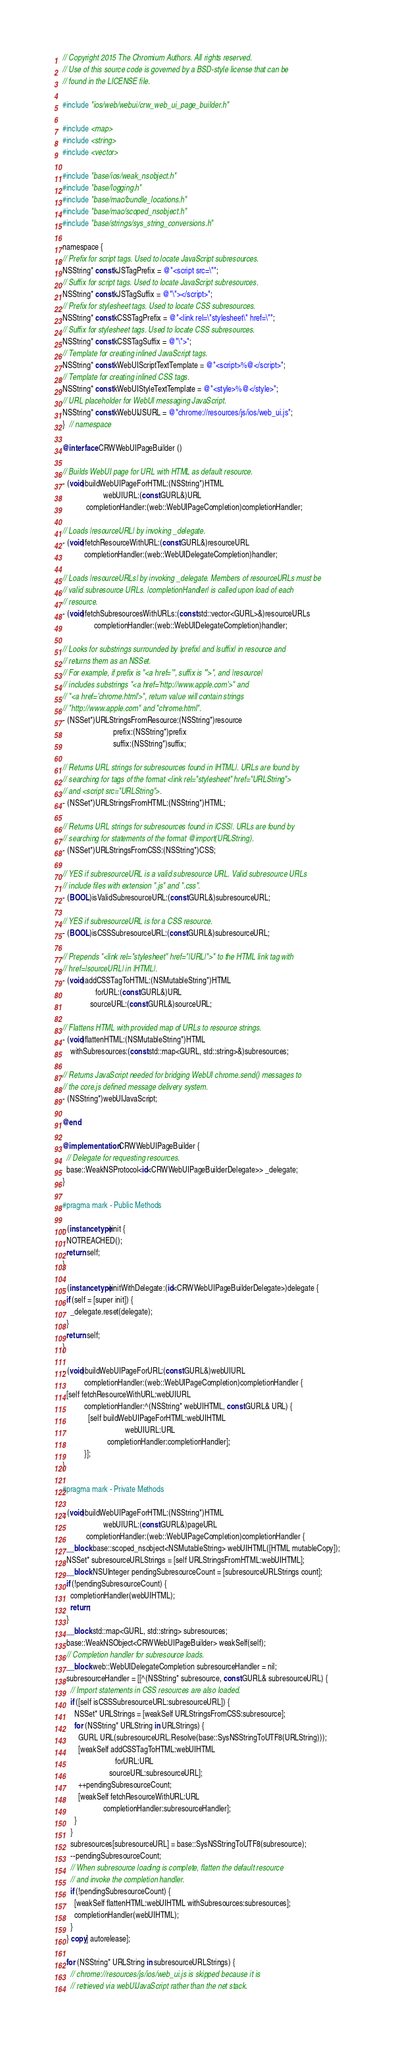Convert code to text. <code><loc_0><loc_0><loc_500><loc_500><_ObjectiveC_>// Copyright 2015 The Chromium Authors. All rights reserved.
// Use of this source code is governed by a BSD-style license that can be
// found in the LICENSE file.

#include "ios/web/webui/crw_web_ui_page_builder.h"

#include <map>
#include <string>
#include <vector>

#include "base/ios/weak_nsobject.h"
#include "base/logging.h"
#include "base/mac/bundle_locations.h"
#include "base/mac/scoped_nsobject.h"
#include "base/strings/sys_string_conversions.h"

namespace {
// Prefix for script tags. Used to locate JavaScript subresources.
NSString* const kJSTagPrefix = @"<script src=\"";
// Suffix for script tags. Used to locate JavaScript subresources.
NSString* const kJSTagSuffix = @"\"></script>";
// Prefix for stylesheet tags. Used to locate CSS subresources.
NSString* const kCSSTagPrefix = @"<link rel=\"stylesheet\" href=\"";
// Suffix for stylesheet tags. Used to locate CSS subresources.
NSString* const kCSSTagSuffix = @"\">";
// Template for creating inlined JavaScript tags.
NSString* const kWebUIScriptTextTemplate = @"<script>%@</script>";
// Template for creating inlined CSS tags.
NSString* const kWebUIStyleTextTemplate = @"<style>%@</style>";
// URL placeholder for WebUI messaging JavaScript.
NSString* const kWebUIJSURL = @"chrome://resources/js/ios/web_ui.js";
}  // namespace

@interface CRWWebUIPageBuilder ()

// Builds WebUI page for URL with HTML as default resource.
- (void)buildWebUIPageForHTML:(NSString*)HTML
                     webUIURL:(const GURL&)URL
            completionHandler:(web::WebUIPageCompletion)completionHandler;

// Loads |resourceURL| by invoking _delegate.
- (void)fetchResourceWithURL:(const GURL&)resourceURL
           completionHandler:(web::WebUIDelegateCompletion)handler;

// Loads |resourceURLs| by invoking _delegate. Members of resourceURLs must be
// valid subresource URLs. |completionHandler| is called upon load of each
// resource.
- (void)fetchSubresourcesWithURLs:(const std::vector<GURL>&)resourceURLs
                completionHandler:(web::WebUIDelegateCompletion)handler;

// Looks for substrings surrounded by |prefix| and |suffix| in resource and
// returns them as an NSSet.
// For example, if prefix is "<a href='", suffix is "'>", and |resource|
// includes substrings "<a href='http://www.apple.com'>" and
// "<a href='chrome.html'>", return value will contain strings
// "http://www.apple.com" and "chrome.html".
- (NSSet*)URLStringsFromResource:(NSString*)resource
                          prefix:(NSString*)prefix
                          suffix:(NSString*)suffix;

// Returns URL strings for subresources found in |HTML|. URLs are found by
// searching for tags of the format <link rel="stylesheet" href="URLString">
// and <script src="URLString">.
- (NSSet*)URLStringsFromHTML:(NSString*)HTML;

// Returns URL strings for subresources found in |CSS|. URLs are found by
// searching for statements of the format @import(URLString).
- (NSSet*)URLStringsFromCSS:(NSString*)CSS;

// YES if subresourceURL is a valid subresource URL. Valid subresource URLs
// include files with extension ".js" and ".css".
- (BOOL)isValidSubresourceURL:(const GURL&)subresourceURL;

// YES if subresourceURL is for a CSS resource.
- (BOOL)isCSSSubresourceURL:(const GURL&)subresourceURL;

// Prepends "<link rel="stylesheet" href="|URL|">" to the HTML link tag with
// href=|sourceURL| in |HTML|.
- (void)addCSSTagToHTML:(NSMutableString*)HTML
                 forURL:(const GURL&)URL
              sourceURL:(const GURL&)sourceURL;

// Flattens HTML with provided map of URLs to resource strings.
- (void)flattenHTML:(NSMutableString*)HTML
    withSubresources:(const std::map<GURL, std::string>&)subresources;

// Returns JavaScript needed for bridging WebUI chrome.send() messages to
// the core.js defined message delivery system.
- (NSString*)webUIJavaScript;

@end

@implementation CRWWebUIPageBuilder {
  // Delegate for requesting resources.
  base::WeakNSProtocol<id<CRWWebUIPageBuilderDelegate>> _delegate;
}

#pragma mark - Public Methods

- (instancetype)init {
  NOTREACHED();
  return self;
}

- (instancetype)initWithDelegate:(id<CRWWebUIPageBuilderDelegate>)delegate {
  if (self = [super init]) {
    _delegate.reset(delegate);
  }
  return self;
}

- (void)buildWebUIPageForURL:(const GURL&)webUIURL
           completionHandler:(web::WebUIPageCompletion)completionHandler {
  [self fetchResourceWithURL:webUIURL
           completionHandler:^(NSString* webUIHTML, const GURL& URL) {
             [self buildWebUIPageForHTML:webUIHTML
                                webUIURL:URL
                       completionHandler:completionHandler];
           }];
}

#pragma mark - Private Methods

- (void)buildWebUIPageForHTML:(NSString*)HTML
                     webUIURL:(const GURL&)pageURL
            completionHandler:(web::WebUIPageCompletion)completionHandler {
  __block base::scoped_nsobject<NSMutableString> webUIHTML([HTML mutableCopy]);
  NSSet* subresourceURLStrings = [self URLStringsFromHTML:webUIHTML];
  __block NSUInteger pendingSubresourceCount = [subresourceURLStrings count];
  if (!pendingSubresourceCount) {
    completionHandler(webUIHTML);
    return;
  }
  __block std::map<GURL, std::string> subresources;
  base::WeakNSObject<CRWWebUIPageBuilder> weakSelf(self);
  // Completion handler for subresource loads.
  __block web::WebUIDelegateCompletion subresourceHandler = nil;
  subresourceHandler = [[^(NSString* subresource, const GURL& subresourceURL) {
    // Import statements in CSS resources are also loaded.
    if ([self isCSSSubresourceURL:subresourceURL]) {
      NSSet* URLStrings = [weakSelf URLStringsFromCSS:subresource];
      for (NSString* URLString in URLStrings) {
        GURL URL(subresourceURL.Resolve(base::SysNSStringToUTF8(URLString)));
        [weakSelf addCSSTagToHTML:webUIHTML
                           forURL:URL
                        sourceURL:subresourceURL];
        ++pendingSubresourceCount;
        [weakSelf fetchResourceWithURL:URL
                     completionHandler:subresourceHandler];
      }
    }
    subresources[subresourceURL] = base::SysNSStringToUTF8(subresource);
    --pendingSubresourceCount;
    // When subresource loading is complete, flatten the default resource
    // and invoke the completion handler.
    if (!pendingSubresourceCount) {
      [weakSelf flattenHTML:webUIHTML withSubresources:subresources];
      completionHandler(webUIHTML);
    }
  } copy] autorelease];

  for (NSString* URLString in subresourceURLStrings) {
    // chrome://resources/js/ios/web_ui.js is skipped because it is
    // retrieved via webUIJavaScript rather than the net stack.</code> 